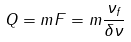<formula> <loc_0><loc_0><loc_500><loc_500>Q = m F = m \frac { \nu _ { f } } { \delta \nu }</formula> 